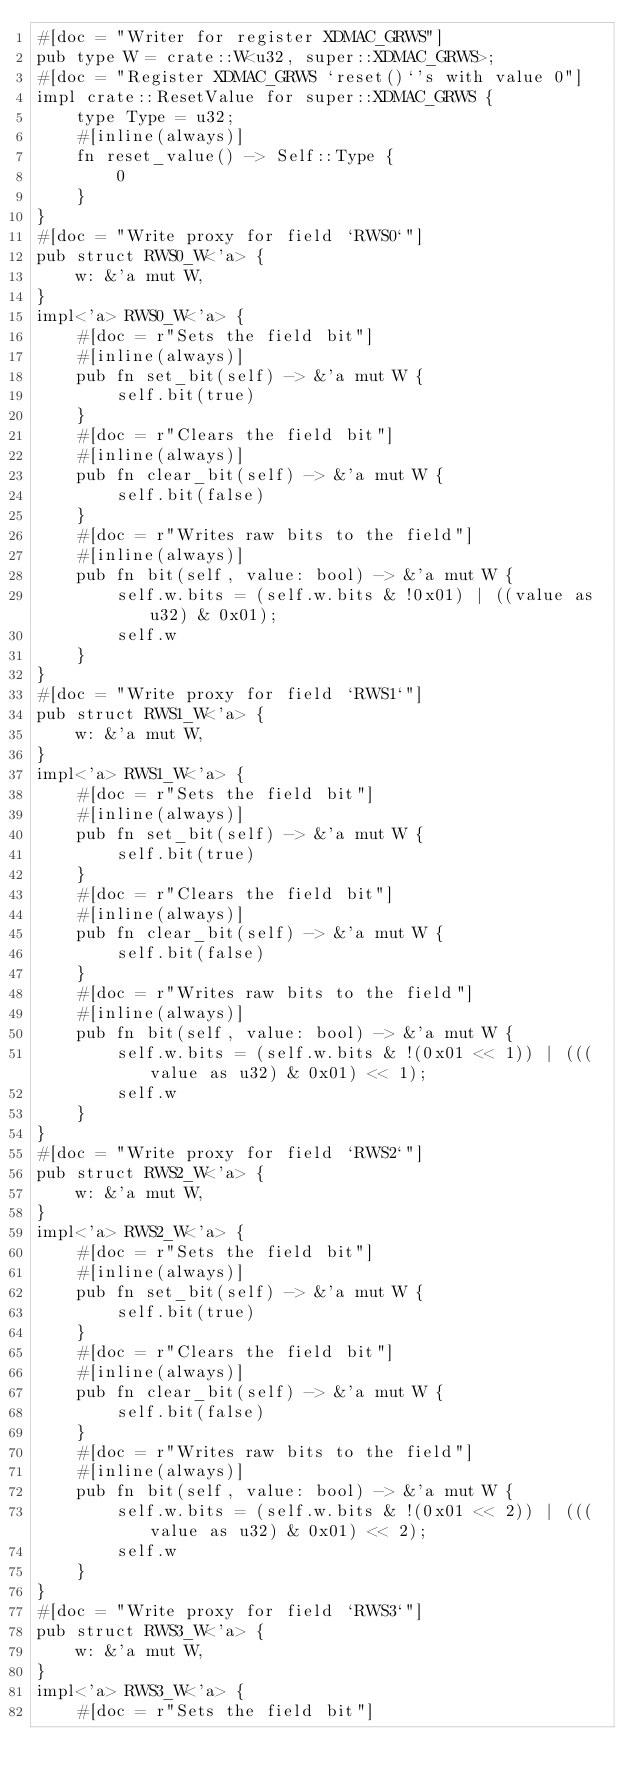<code> <loc_0><loc_0><loc_500><loc_500><_Rust_>#[doc = "Writer for register XDMAC_GRWS"]
pub type W = crate::W<u32, super::XDMAC_GRWS>;
#[doc = "Register XDMAC_GRWS `reset()`'s with value 0"]
impl crate::ResetValue for super::XDMAC_GRWS {
    type Type = u32;
    #[inline(always)]
    fn reset_value() -> Self::Type {
        0
    }
}
#[doc = "Write proxy for field `RWS0`"]
pub struct RWS0_W<'a> {
    w: &'a mut W,
}
impl<'a> RWS0_W<'a> {
    #[doc = r"Sets the field bit"]
    #[inline(always)]
    pub fn set_bit(self) -> &'a mut W {
        self.bit(true)
    }
    #[doc = r"Clears the field bit"]
    #[inline(always)]
    pub fn clear_bit(self) -> &'a mut W {
        self.bit(false)
    }
    #[doc = r"Writes raw bits to the field"]
    #[inline(always)]
    pub fn bit(self, value: bool) -> &'a mut W {
        self.w.bits = (self.w.bits & !0x01) | ((value as u32) & 0x01);
        self.w
    }
}
#[doc = "Write proxy for field `RWS1`"]
pub struct RWS1_W<'a> {
    w: &'a mut W,
}
impl<'a> RWS1_W<'a> {
    #[doc = r"Sets the field bit"]
    #[inline(always)]
    pub fn set_bit(self) -> &'a mut W {
        self.bit(true)
    }
    #[doc = r"Clears the field bit"]
    #[inline(always)]
    pub fn clear_bit(self) -> &'a mut W {
        self.bit(false)
    }
    #[doc = r"Writes raw bits to the field"]
    #[inline(always)]
    pub fn bit(self, value: bool) -> &'a mut W {
        self.w.bits = (self.w.bits & !(0x01 << 1)) | (((value as u32) & 0x01) << 1);
        self.w
    }
}
#[doc = "Write proxy for field `RWS2`"]
pub struct RWS2_W<'a> {
    w: &'a mut W,
}
impl<'a> RWS2_W<'a> {
    #[doc = r"Sets the field bit"]
    #[inline(always)]
    pub fn set_bit(self) -> &'a mut W {
        self.bit(true)
    }
    #[doc = r"Clears the field bit"]
    #[inline(always)]
    pub fn clear_bit(self) -> &'a mut W {
        self.bit(false)
    }
    #[doc = r"Writes raw bits to the field"]
    #[inline(always)]
    pub fn bit(self, value: bool) -> &'a mut W {
        self.w.bits = (self.w.bits & !(0x01 << 2)) | (((value as u32) & 0x01) << 2);
        self.w
    }
}
#[doc = "Write proxy for field `RWS3`"]
pub struct RWS3_W<'a> {
    w: &'a mut W,
}
impl<'a> RWS3_W<'a> {
    #[doc = r"Sets the field bit"]</code> 